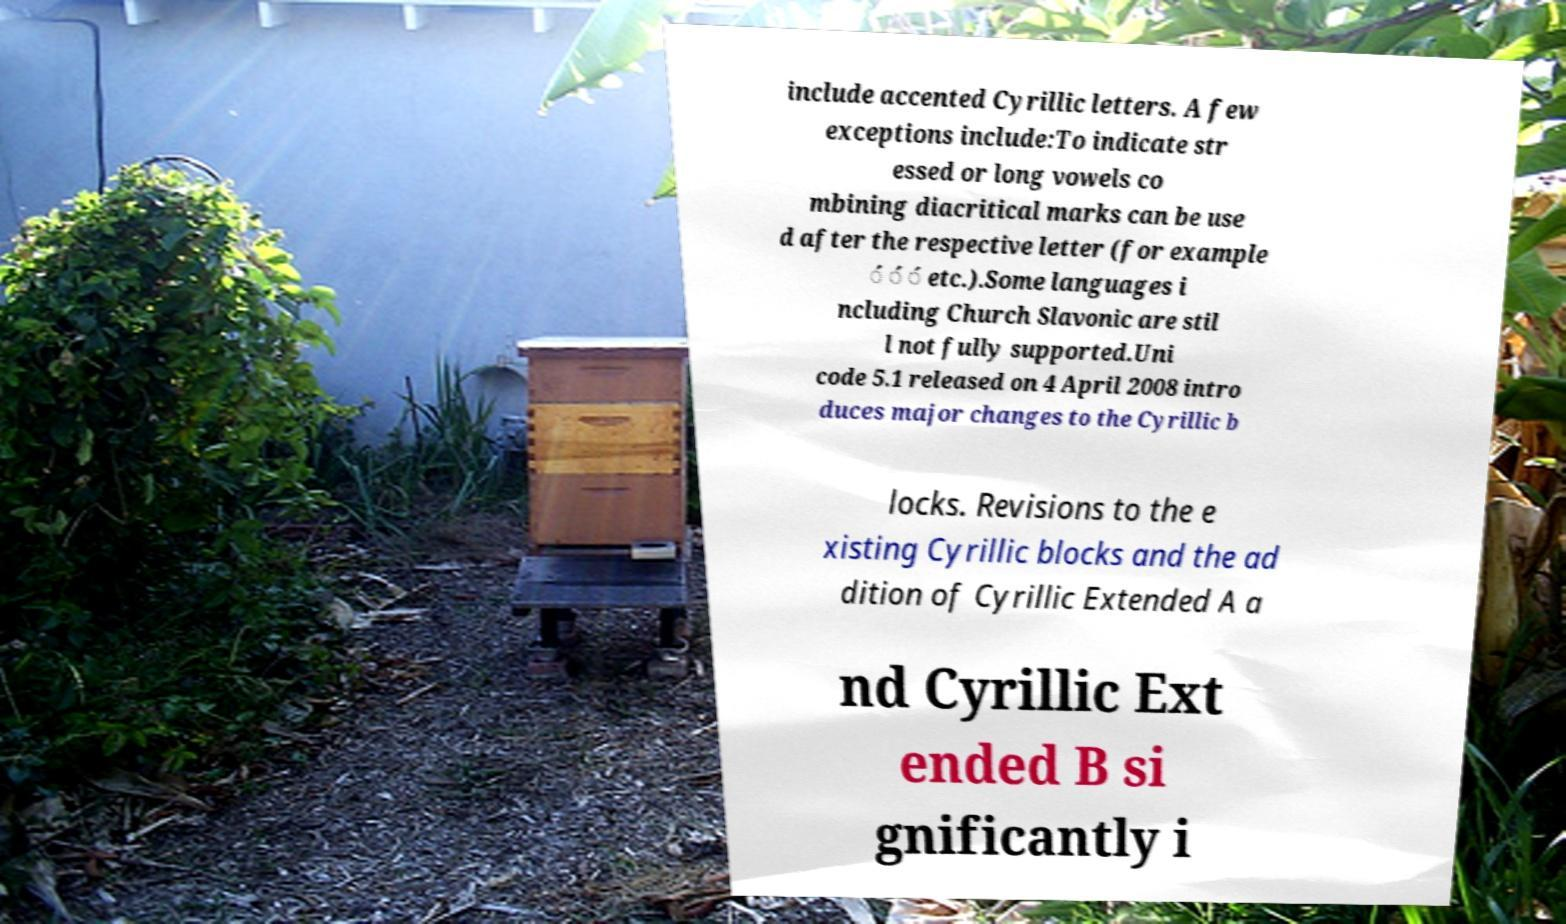Could you extract and type out the text from this image? include accented Cyrillic letters. A few exceptions include:To indicate str essed or long vowels co mbining diacritical marks can be use d after the respective letter (for example ́ ́ ́ etc.).Some languages i ncluding Church Slavonic are stil l not fully supported.Uni code 5.1 released on 4 April 2008 intro duces major changes to the Cyrillic b locks. Revisions to the e xisting Cyrillic blocks and the ad dition of Cyrillic Extended A a nd Cyrillic Ext ended B si gnificantly i 